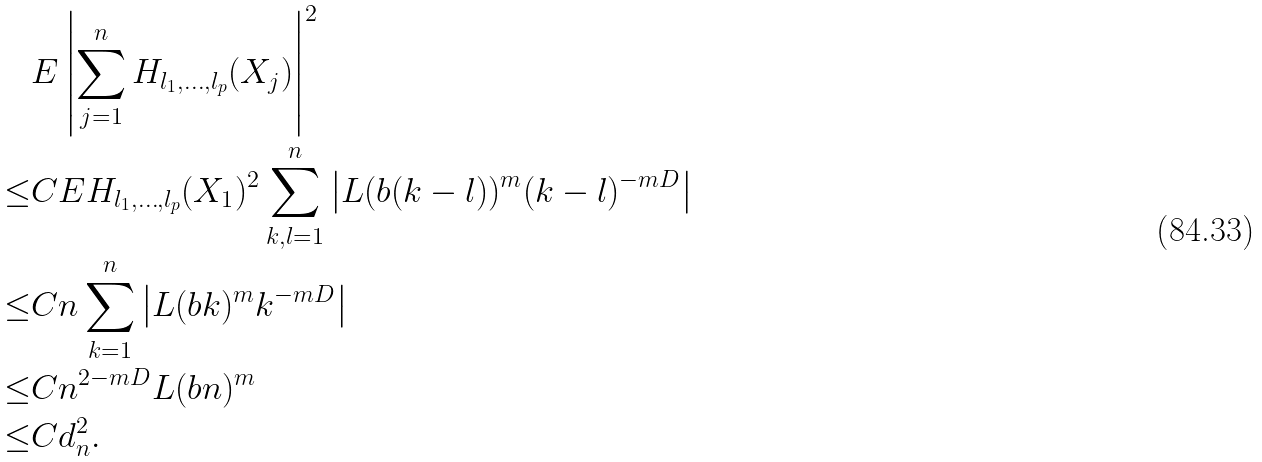<formula> <loc_0><loc_0><loc_500><loc_500>& E \left | \sum _ { j = 1 } ^ { n } H _ { l _ { 1 } , \dots , l _ { p } } ( X _ { j } ) \right | ^ { 2 } \\ \leq & C E H _ { l _ { 1 } , \dots , l _ { p } } ( X _ { 1 } ) ^ { 2 } \sum _ { k , l = 1 } ^ { n } \left | L ( b ( k - l ) ) ^ { m } ( k - l ) ^ { - m D } \right | \\ \leq & C n \sum _ { k = 1 } ^ { n } \left | L ( b k ) ^ { m } k ^ { - m D } \right | \\ \leq & C n ^ { 2 - m D } L ( b n ) ^ { m } \\ \leq & C d _ { n } ^ { 2 } .</formula> 